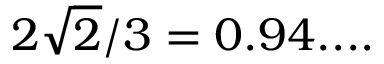<formula> <loc_0><loc_0><loc_500><loc_500>2 { \sqrt { 2 } } / 3 = 0 . 9 4 \cdots</formula> 